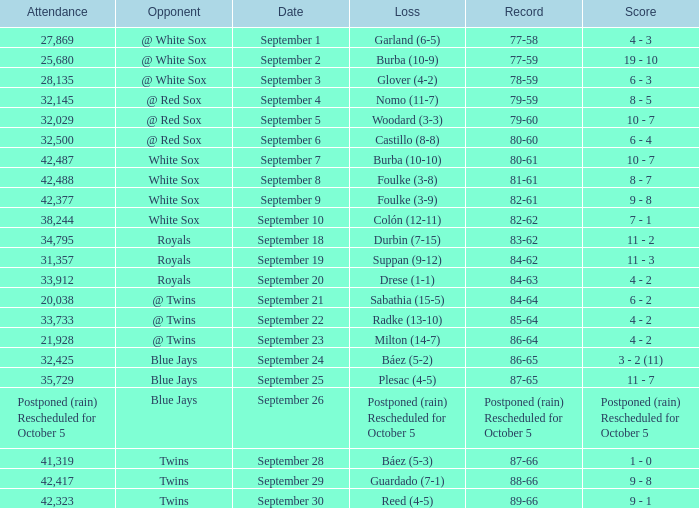What is the score of the game that holds a record of 80-61? 10 - 7. 